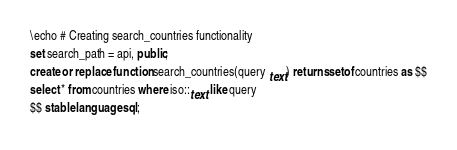Convert code to text. <code><loc_0><loc_0><loc_500><loc_500><_SQL_>\echo # Creating search_countries functionality
set search_path = api, public;
create or replace function search_countries(query text) returns setof countries as $$
select * from countries where iso::text like query
$$ stable language sql;
</code> 